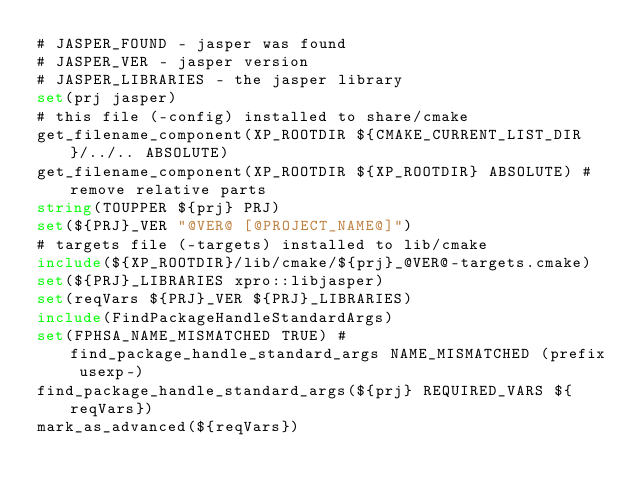<code> <loc_0><loc_0><loc_500><loc_500><_CMake_># JASPER_FOUND - jasper was found
# JASPER_VER - jasper version
# JASPER_LIBRARIES - the jasper library
set(prj jasper)
# this file (-config) installed to share/cmake
get_filename_component(XP_ROOTDIR ${CMAKE_CURRENT_LIST_DIR}/../.. ABSOLUTE)
get_filename_component(XP_ROOTDIR ${XP_ROOTDIR} ABSOLUTE) # remove relative parts
string(TOUPPER ${prj} PRJ)
set(${PRJ}_VER "@VER@ [@PROJECT_NAME@]")
# targets file (-targets) installed to lib/cmake
include(${XP_ROOTDIR}/lib/cmake/${prj}_@VER@-targets.cmake)
set(${PRJ}_LIBRARIES xpro::libjasper)
set(reqVars ${PRJ}_VER ${PRJ}_LIBRARIES)
include(FindPackageHandleStandardArgs)
set(FPHSA_NAME_MISMATCHED TRUE) # find_package_handle_standard_args NAME_MISMATCHED (prefix usexp-)
find_package_handle_standard_args(${prj} REQUIRED_VARS ${reqVars})
mark_as_advanced(${reqVars})
</code> 